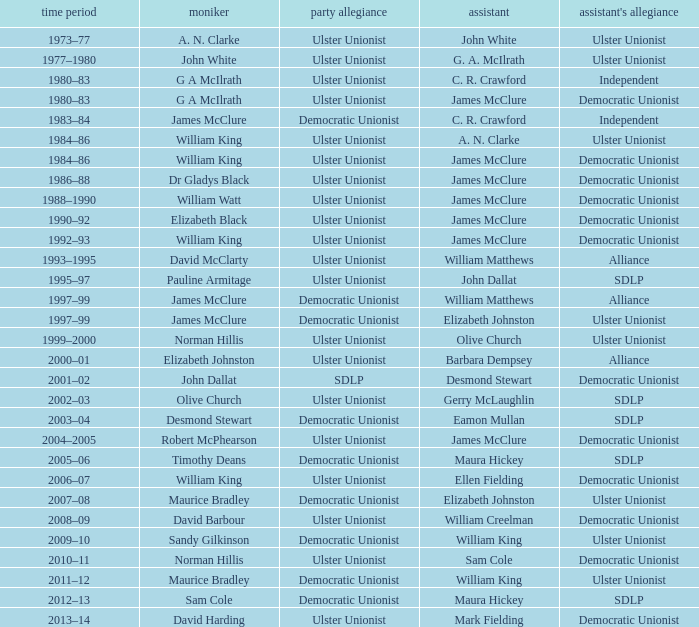What Year was james mcclure Deputy, and the Name is robert mcphearson? 2004–2005. 